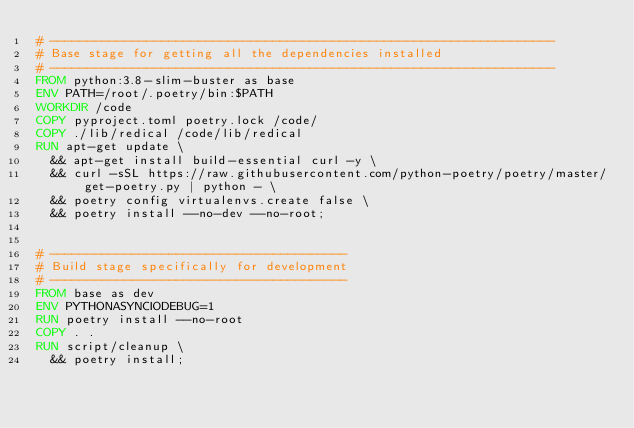Convert code to text. <code><loc_0><loc_0><loc_500><loc_500><_Dockerfile_># --------------------------------------------------------------------
# Base stage for getting all the dependencies installed
# --------------------------------------------------------------------
FROM python:3.8-slim-buster as base
ENV PATH=/root/.poetry/bin:$PATH
WORKDIR /code
COPY pyproject.toml poetry.lock /code/
COPY ./lib/redical /code/lib/redical
RUN apt-get update \
	&& apt-get install build-essential curl -y \
	&& curl -sSL https://raw.githubusercontent.com/python-poetry/poetry/master/get-poetry.py | python - \
	&& poetry config virtualenvs.create false \
	&& poetry install --no-dev --no-root;


# ----------------------------------------
# Build stage specifically for development
# ----------------------------------------
FROM base as dev
ENV PYTHONASYNCIODEBUG=1
RUN poetry install --no-root
COPY . .
RUN script/cleanup \
	&& poetry install;
</code> 